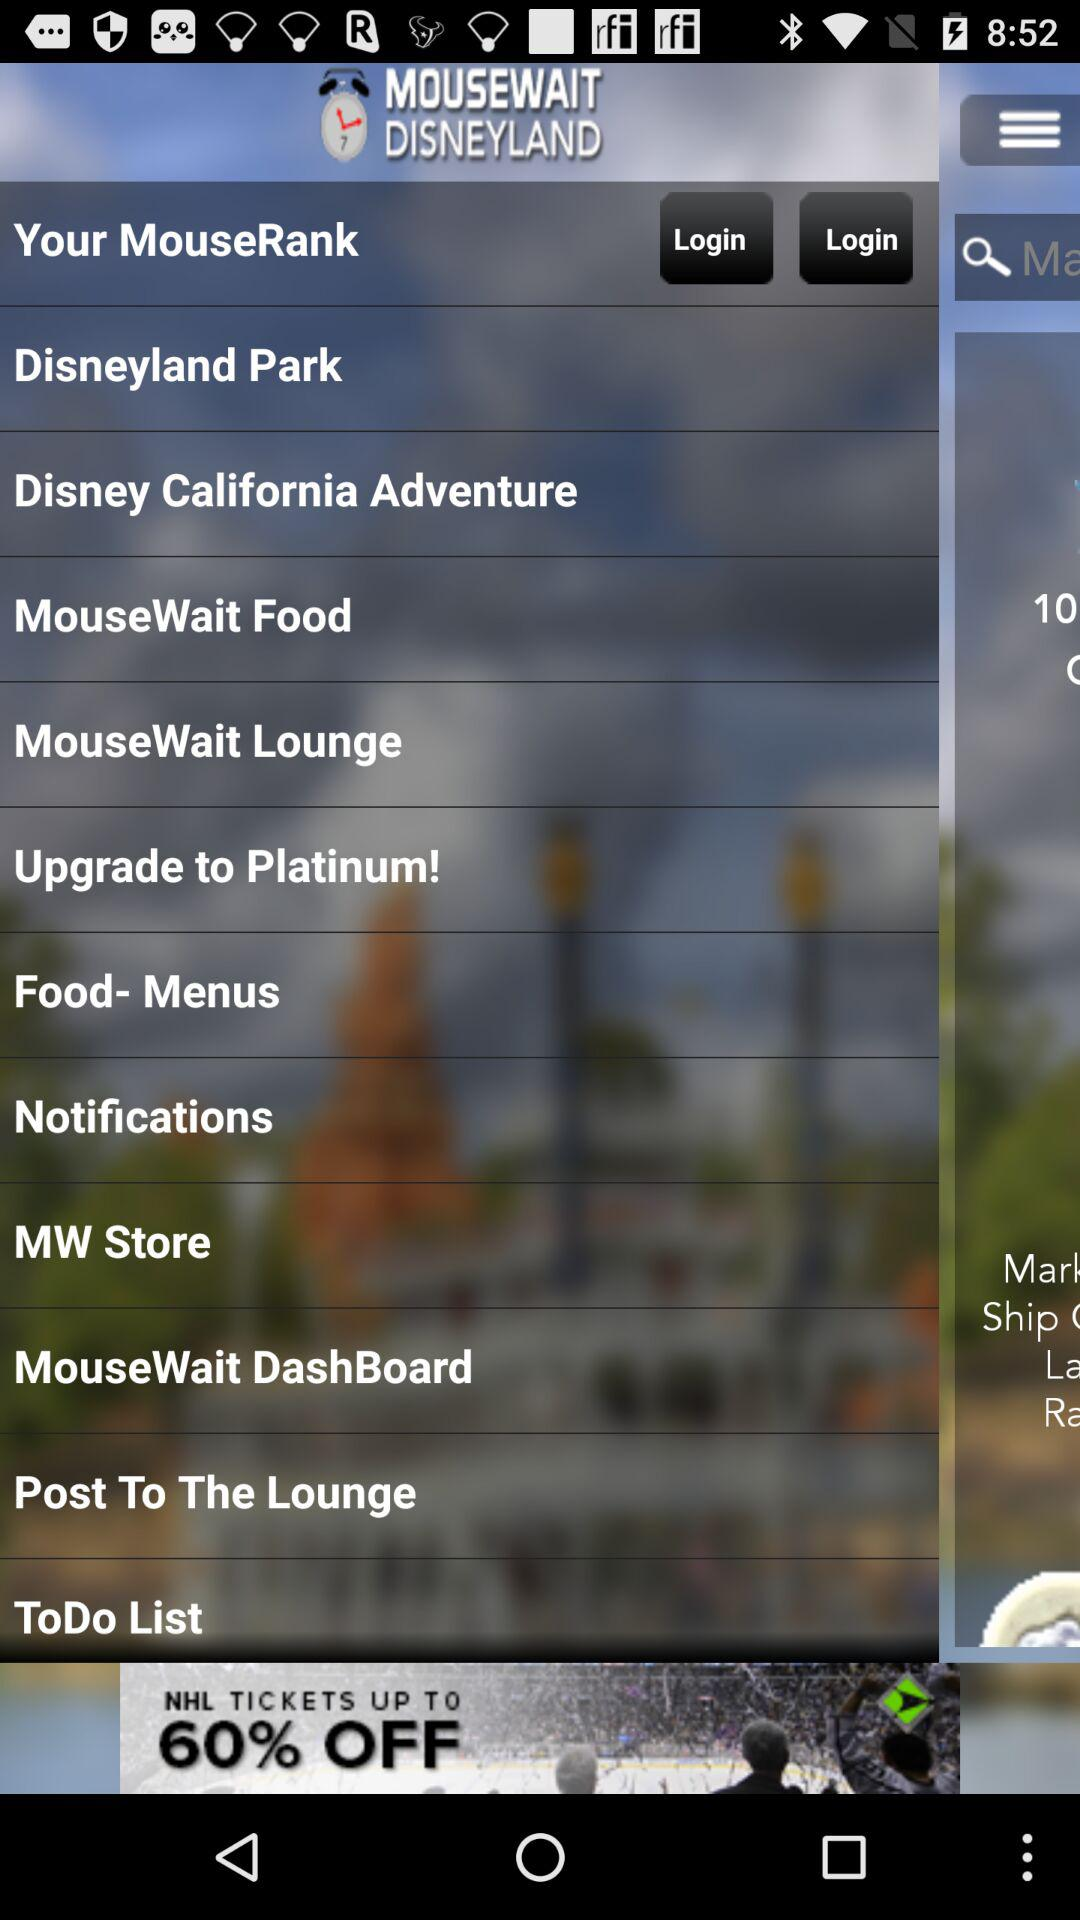What is the name of the application? The name of the application is "MOUSEWAIT DISNEYLAND". 